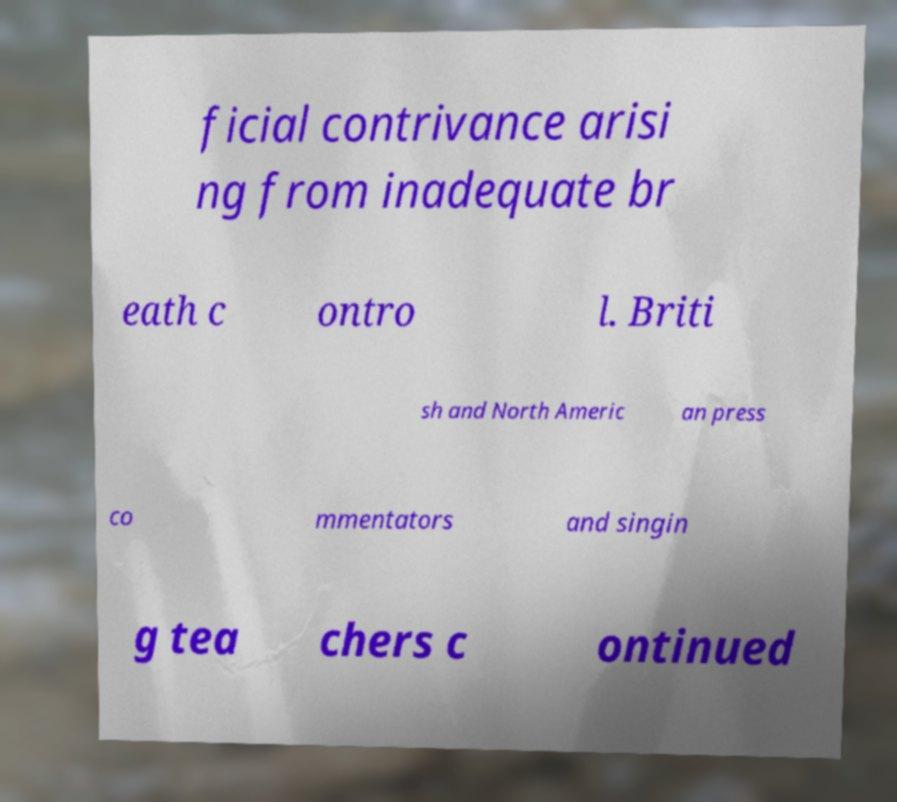Can you read and provide the text displayed in the image?This photo seems to have some interesting text. Can you extract and type it out for me? ficial contrivance arisi ng from inadequate br eath c ontro l. Briti sh and North Americ an press co mmentators and singin g tea chers c ontinued 